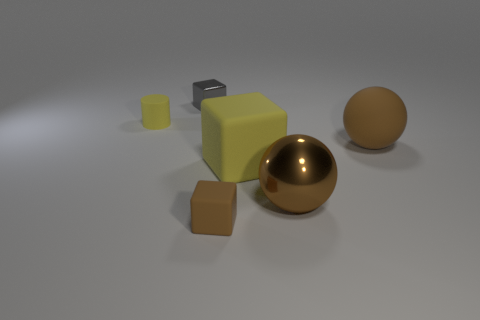Are there more matte cylinders than rubber blocks?
Your answer should be very brief. No. Does the large cube have the same color as the rubber cylinder?
Offer a very short reply. Yes. How many objects are big purple objects or small objects that are behind the matte cylinder?
Your answer should be very brief. 1. How many other objects are there of the same shape as the large brown matte object?
Make the answer very short. 1. Is the number of yellow matte cylinders to the right of the rubber sphere less than the number of large brown metallic things in front of the brown rubber block?
Your response must be concise. No. There is a big yellow thing that is made of the same material as the small yellow object; what shape is it?
Your response must be concise. Cube. Are there any other things of the same color as the tiny metallic block?
Offer a terse response. No. There is a metal object that is behind the sphere that is behind the large shiny thing; what color is it?
Your answer should be very brief. Gray. What material is the yellow thing in front of the brown matte object that is right of the brown sphere that is left of the large brown rubber ball?
Offer a very short reply. Rubber. How many cylinders are the same size as the brown block?
Ensure brevity in your answer.  1. 